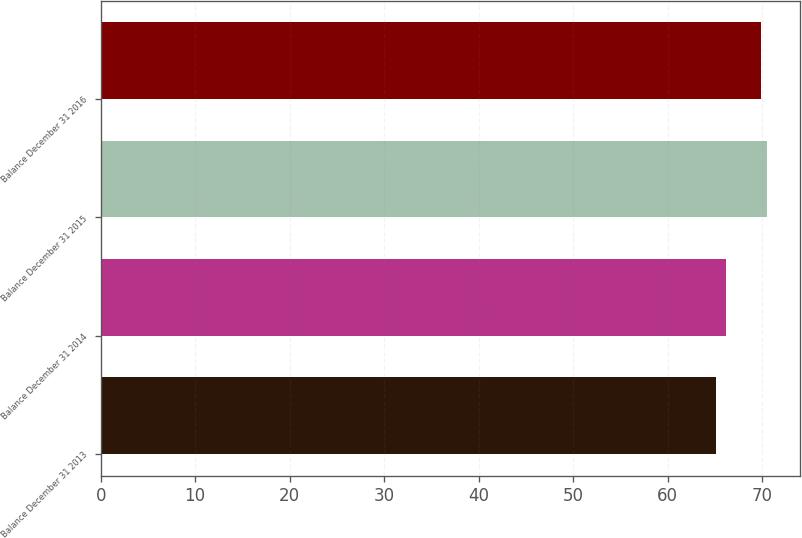<chart> <loc_0><loc_0><loc_500><loc_500><bar_chart><fcel>Balance December 31 2013<fcel>Balance December 31 2014<fcel>Balance December 31 2015<fcel>Balance December 31 2016<nl><fcel>65.1<fcel>66.2<fcel>70.5<fcel>69.8<nl></chart> 